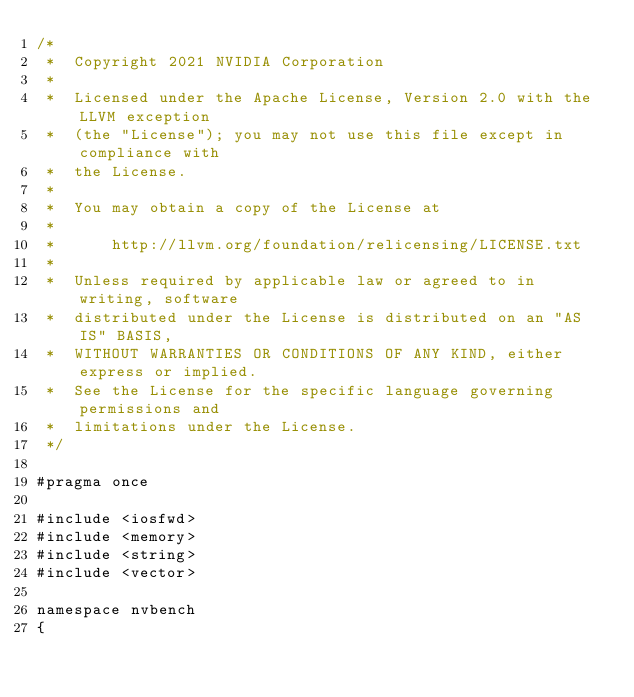Convert code to text. <code><loc_0><loc_0><loc_500><loc_500><_Cuda_>/*
 *  Copyright 2021 NVIDIA Corporation
 *
 *  Licensed under the Apache License, Version 2.0 with the LLVM exception
 *  (the "License"); you may not use this file except in compliance with
 *  the License.
 *
 *  You may obtain a copy of the License at
 *
 *      http://llvm.org/foundation/relicensing/LICENSE.txt
 *
 *  Unless required by applicable law or agreed to in writing, software
 *  distributed under the License is distributed on an "AS IS" BASIS,
 *  WITHOUT WARRANTIES OR CONDITIONS OF ANY KIND, either express or implied.
 *  See the License for the specific language governing permissions and
 *  limitations under the License.
 */

#pragma once

#include <iosfwd>
#include <memory>
#include <string>
#include <vector>

namespace nvbench
{
</code> 